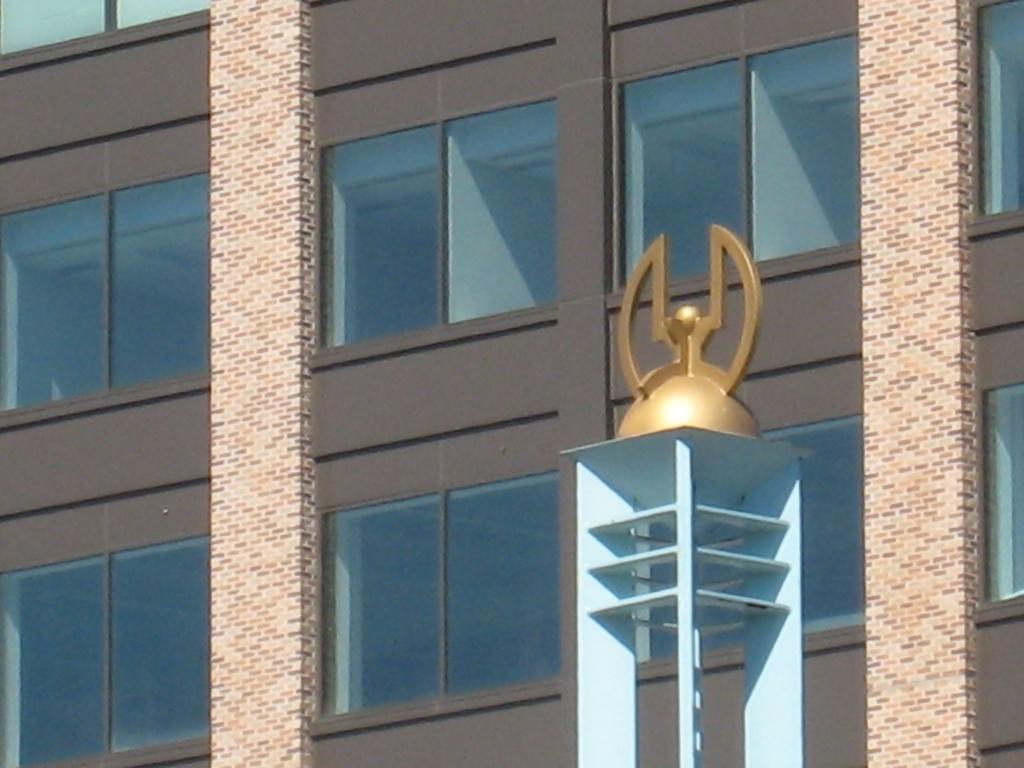What type of structure is present in the picture? There is a building in the picture. What feature can be observed on the building? The building has glass windows. What other notable element is in the picture? There is a tower in the picture. Can you describe the tower? The tower has a symbol on it. What type of brush can be seen cleaning the veins of the building in the image? There is no brush or cleaning activity depicted in the image. Additionally, buildings do not have veins like living organisms. 